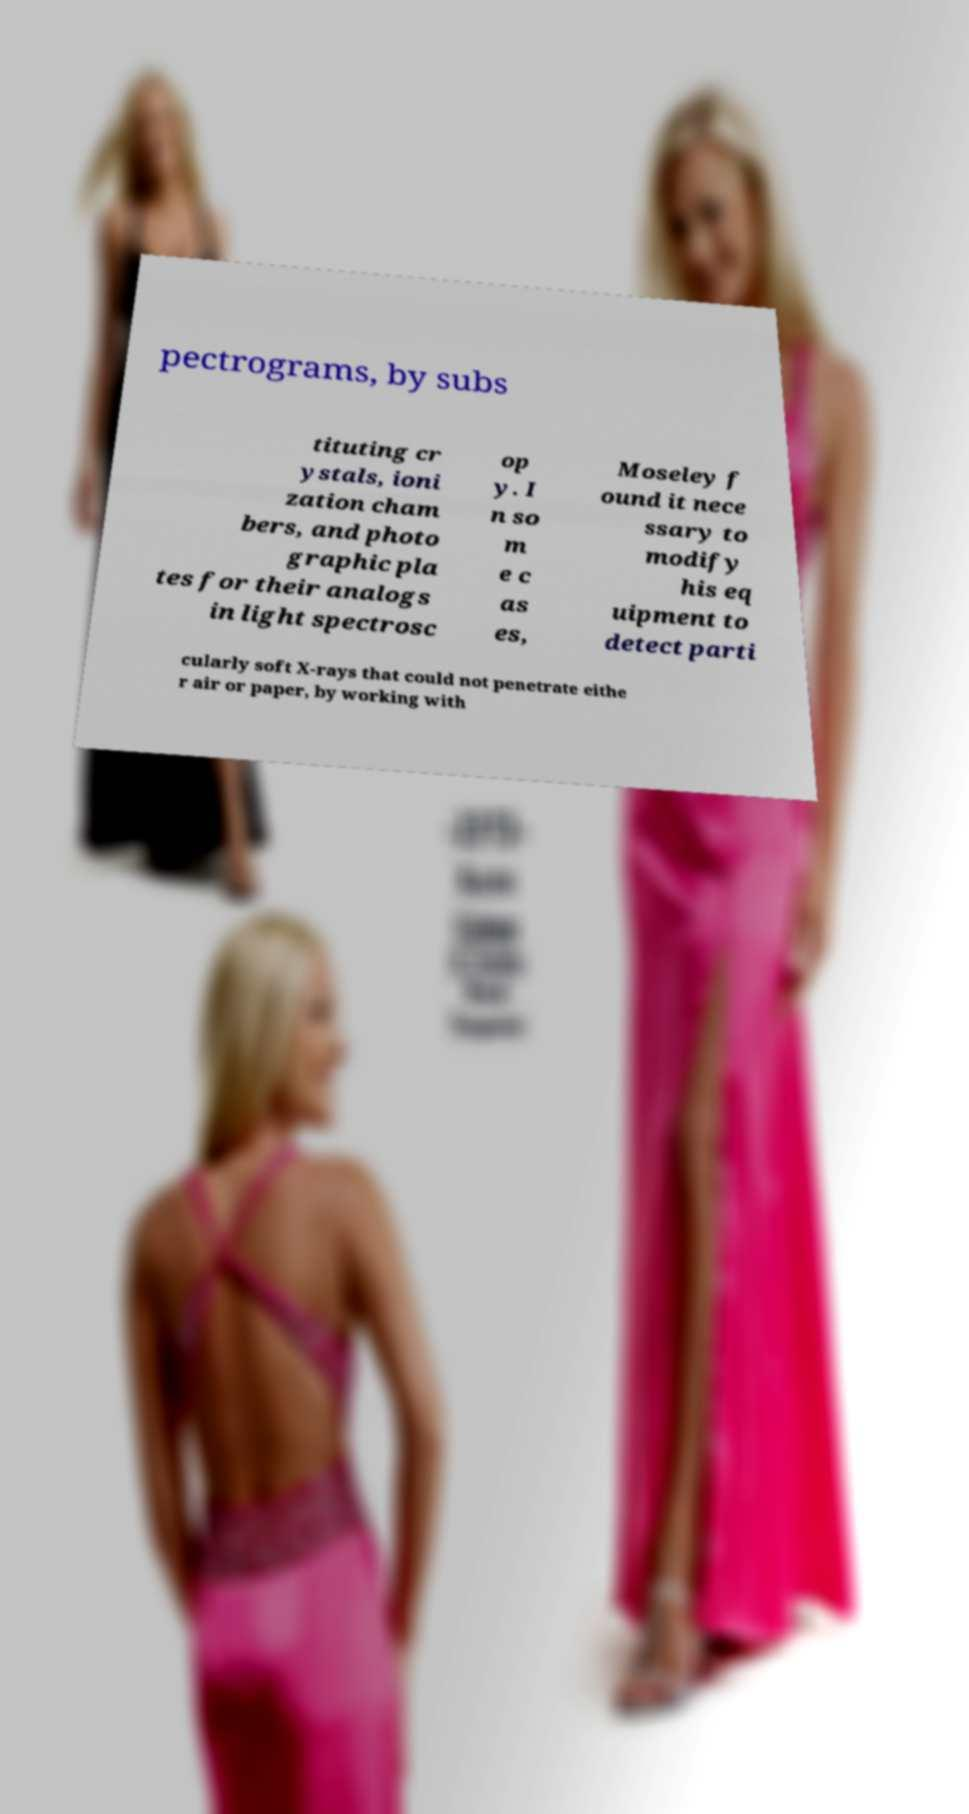I need the written content from this picture converted into text. Can you do that? pectrograms, by subs tituting cr ystals, ioni zation cham bers, and photo graphic pla tes for their analogs in light spectrosc op y. I n so m e c as es, Moseley f ound it nece ssary to modify his eq uipment to detect parti cularly soft X-rays that could not penetrate eithe r air or paper, by working with 